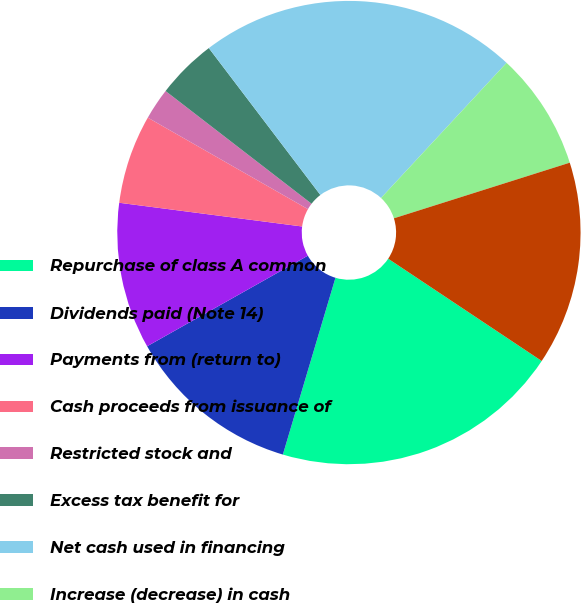<chart> <loc_0><loc_0><loc_500><loc_500><pie_chart><fcel>Repurchase of class A common<fcel>Dividends paid (Note 14)<fcel>Payments from (return to)<fcel>Cash proceeds from issuance of<fcel>Restricted stock and<fcel>Excess tax benefit for<fcel>Net cash used in financing<fcel>Increase (decrease) in cash<fcel>Cash and cash equivalents at<nl><fcel>20.25%<fcel>12.23%<fcel>10.22%<fcel>6.21%<fcel>2.2%<fcel>4.2%<fcel>22.25%<fcel>8.21%<fcel>14.23%<nl></chart> 